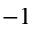Convert formula to latex. <formula><loc_0><loc_0><loc_500><loc_500>^ { - 1 }</formula> 